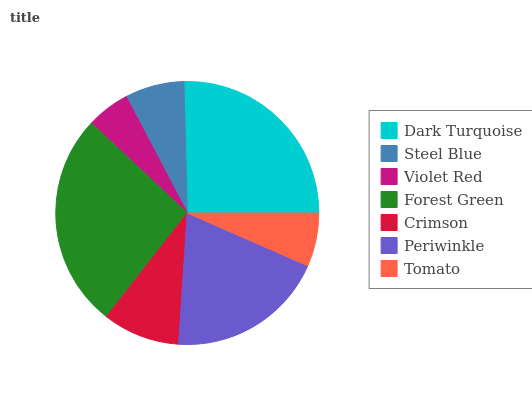Is Violet Red the minimum?
Answer yes or no. Yes. Is Forest Green the maximum?
Answer yes or no. Yes. Is Steel Blue the minimum?
Answer yes or no. No. Is Steel Blue the maximum?
Answer yes or no. No. Is Dark Turquoise greater than Steel Blue?
Answer yes or no. Yes. Is Steel Blue less than Dark Turquoise?
Answer yes or no. Yes. Is Steel Blue greater than Dark Turquoise?
Answer yes or no. No. Is Dark Turquoise less than Steel Blue?
Answer yes or no. No. Is Crimson the high median?
Answer yes or no. Yes. Is Crimson the low median?
Answer yes or no. Yes. Is Steel Blue the high median?
Answer yes or no. No. Is Tomato the low median?
Answer yes or no. No. 